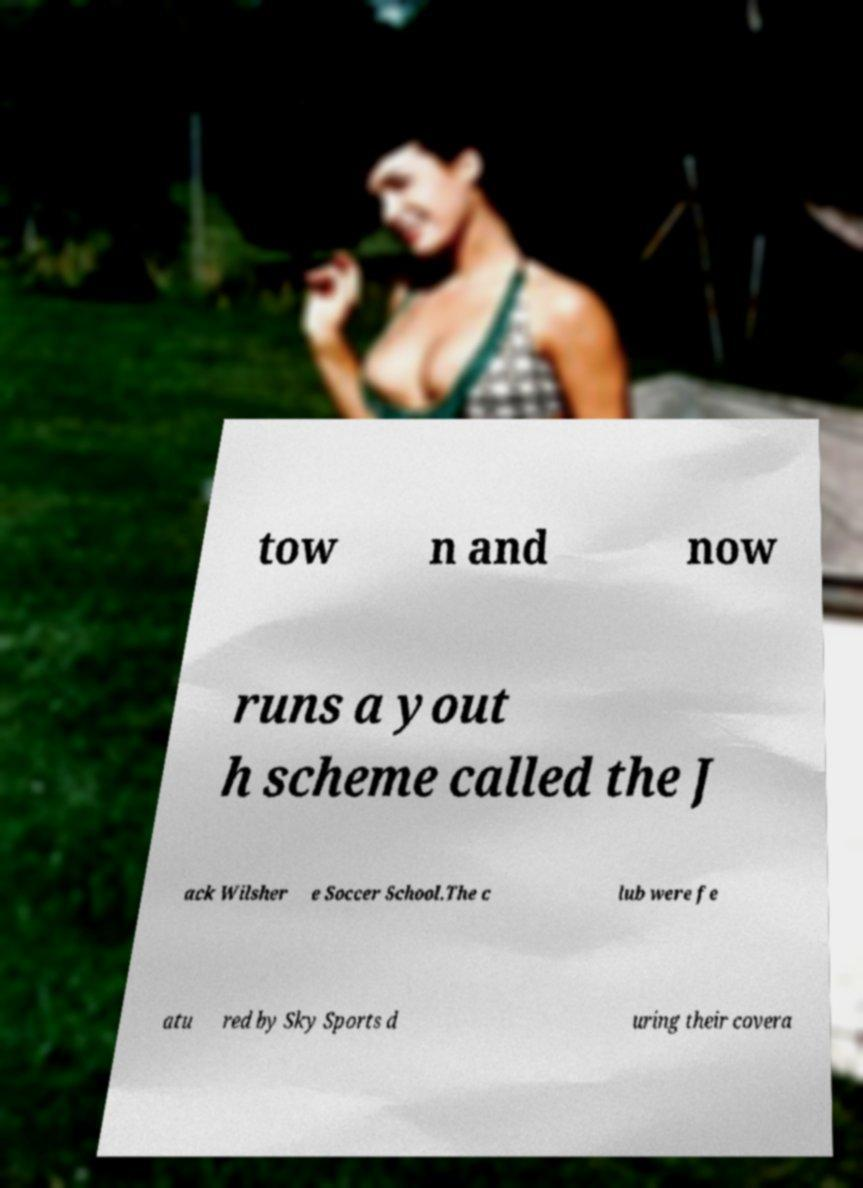Please read and relay the text visible in this image. What does it say? tow n and now runs a yout h scheme called the J ack Wilsher e Soccer School.The c lub were fe atu red by Sky Sports d uring their covera 